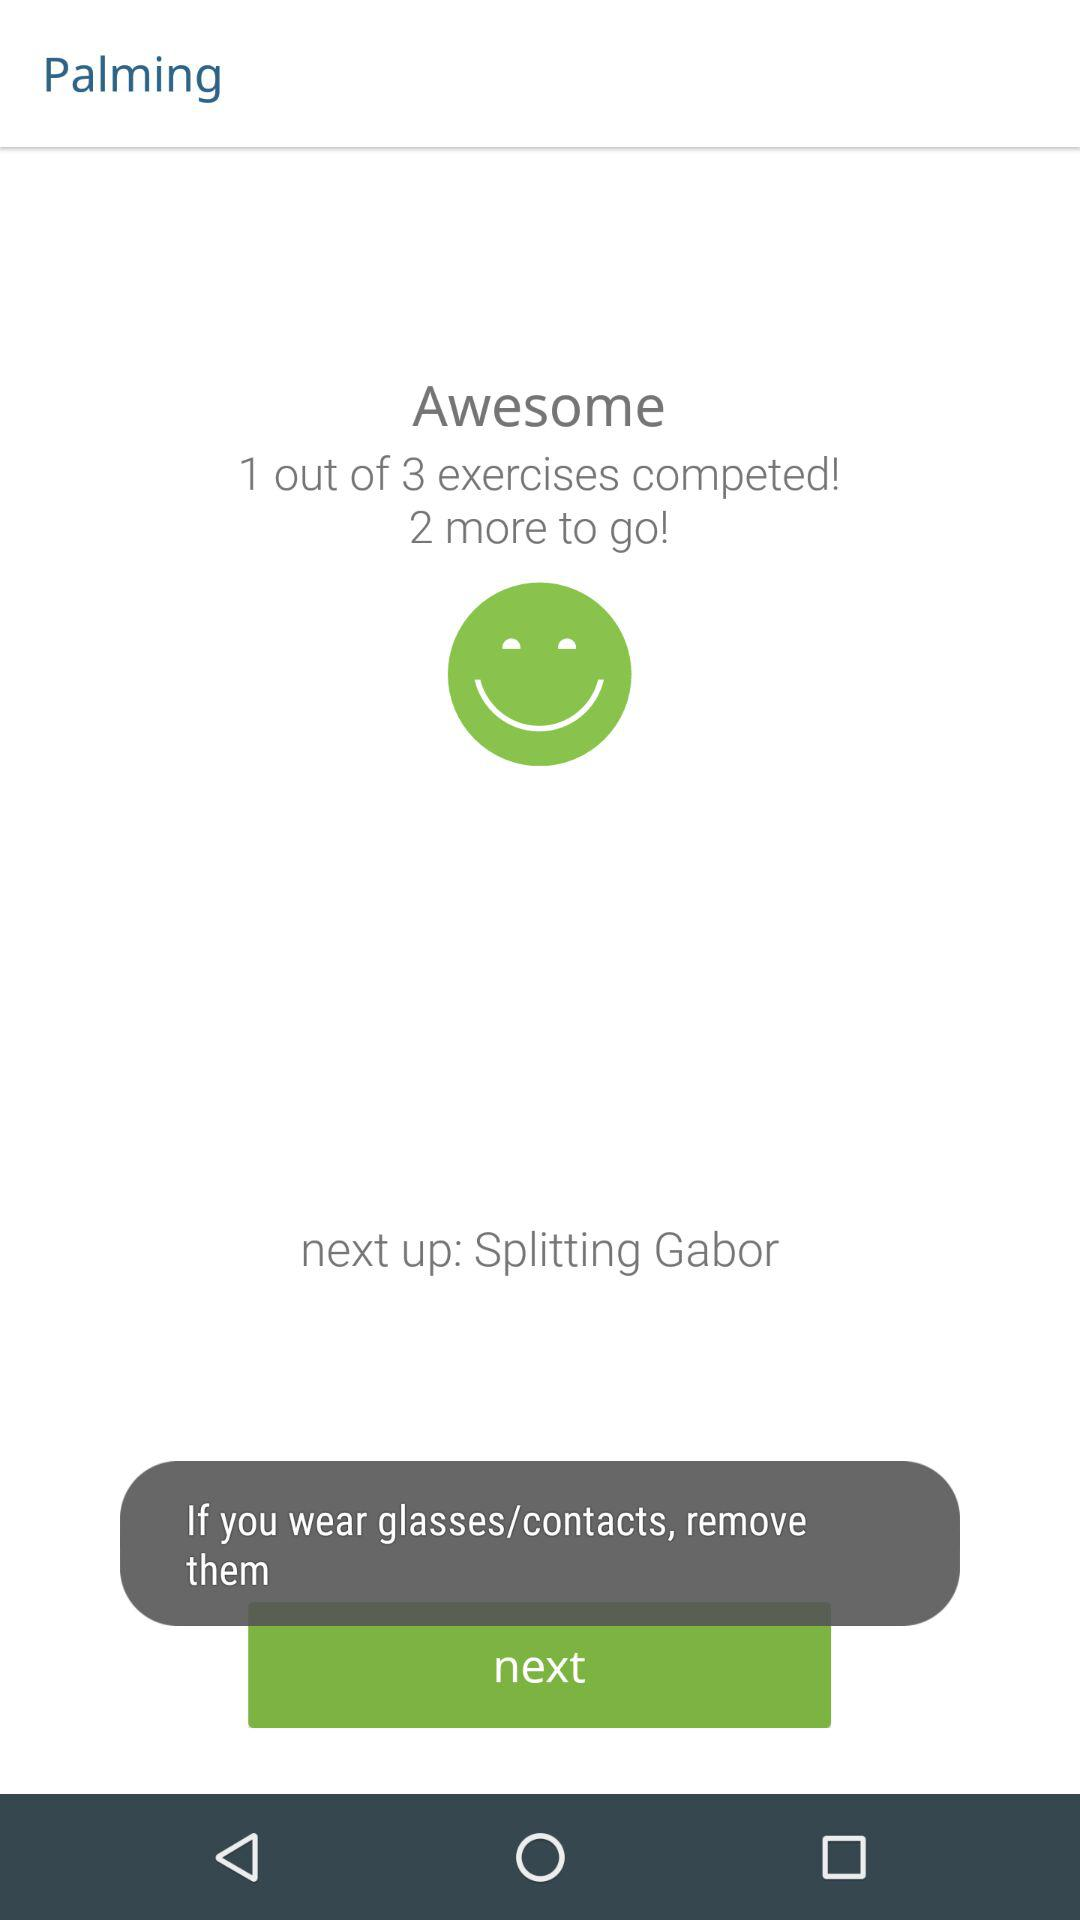How many more exercises are left to complete?
Answer the question using a single word or phrase. 2 